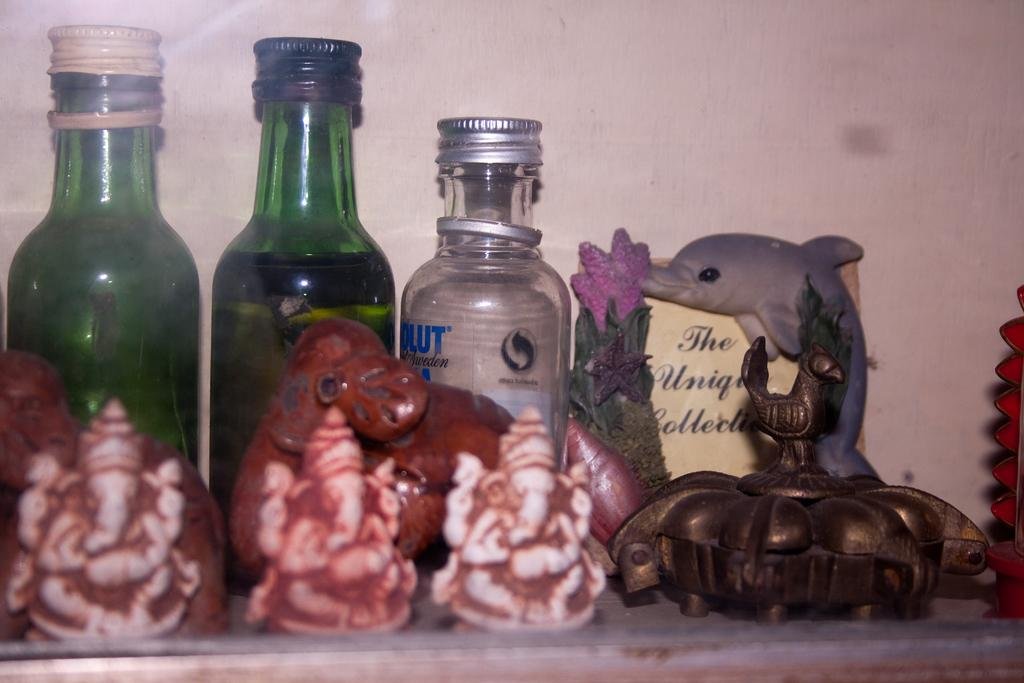What objects can be seen in the image? There are bottles and idols on a table in the image. Can you describe the bottles in the image? The provided facts do not give specific details about the bottles, so we cannot describe them further. What is the table with idols situated on? The provided facts do not give information about the table's surroundings or location. What type of fruit is being used to write on the hall floor in the image? There is no fruit present in the image, and the provided facts do not mention any writing or hall floor. 